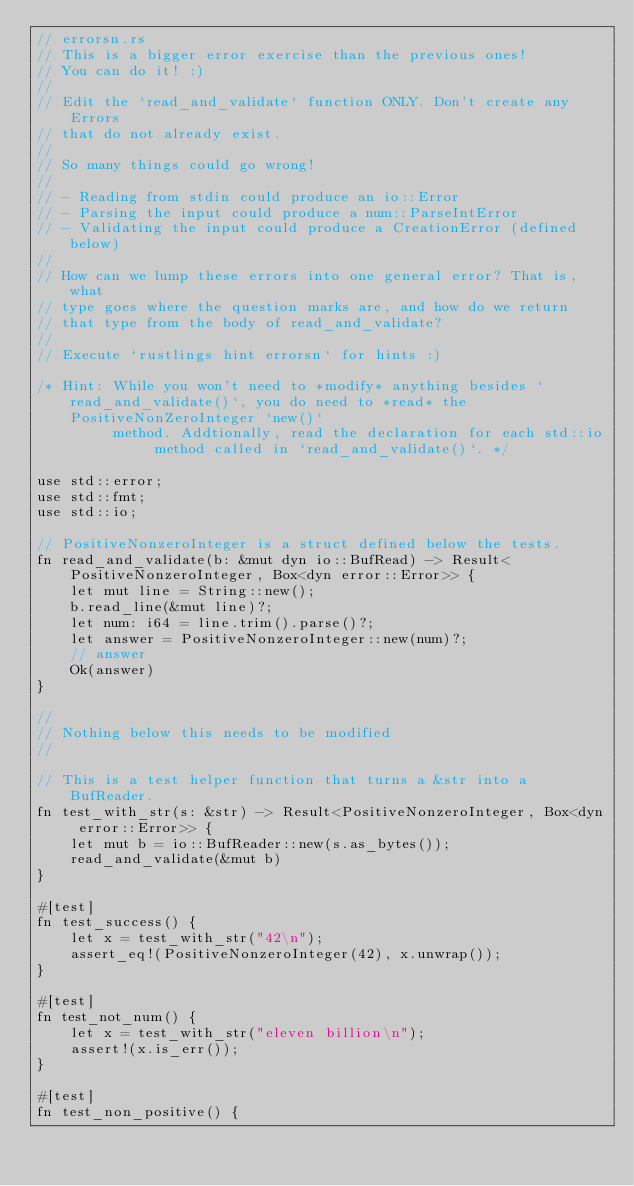Convert code to text. <code><loc_0><loc_0><loc_500><loc_500><_Rust_>// errorsn.rs
// This is a bigger error exercise than the previous ones!
// You can do it! :)
//
// Edit the `read_and_validate` function ONLY. Don't create any Errors
// that do not already exist.
//
// So many things could go wrong!
//
// - Reading from stdin could produce an io::Error
// - Parsing the input could produce a num::ParseIntError
// - Validating the input could produce a CreationError (defined below)
//
// How can we lump these errors into one general error? That is, what
// type goes where the question marks are, and how do we return
// that type from the body of read_and_validate?
//
// Execute `rustlings hint errorsn` for hints :)

/* Hint: While you won't need to *modify* anything besides `read_and_validate()`, you do need to *read* the PositiveNonZeroInteger `new()`
         method. Addtionally, read the declaration for each std::io method called in `read_and_validate()`. */

use std::error;
use std::fmt;
use std::io;

// PositiveNonzeroInteger is a struct defined below the tests.
fn read_and_validate(b: &mut dyn io::BufRead) -> Result<PositiveNonzeroInteger, Box<dyn error::Error>> {
    let mut line = String::new();
    b.read_line(&mut line)?;
    let num: i64 = line.trim().parse()?;
    let answer = PositiveNonzeroInteger::new(num)?;
    // answer
    Ok(answer)
}

//
// Nothing below this needs to be modified
//

// This is a test helper function that turns a &str into a BufReader.
fn test_with_str(s: &str) -> Result<PositiveNonzeroInteger, Box<dyn error::Error>> {
    let mut b = io::BufReader::new(s.as_bytes());
    read_and_validate(&mut b)
}

#[test]
fn test_success() {
    let x = test_with_str("42\n");
    assert_eq!(PositiveNonzeroInteger(42), x.unwrap());
}

#[test]
fn test_not_num() {
    let x = test_with_str("eleven billion\n");
    assert!(x.is_err());
}

#[test]
fn test_non_positive() {</code> 